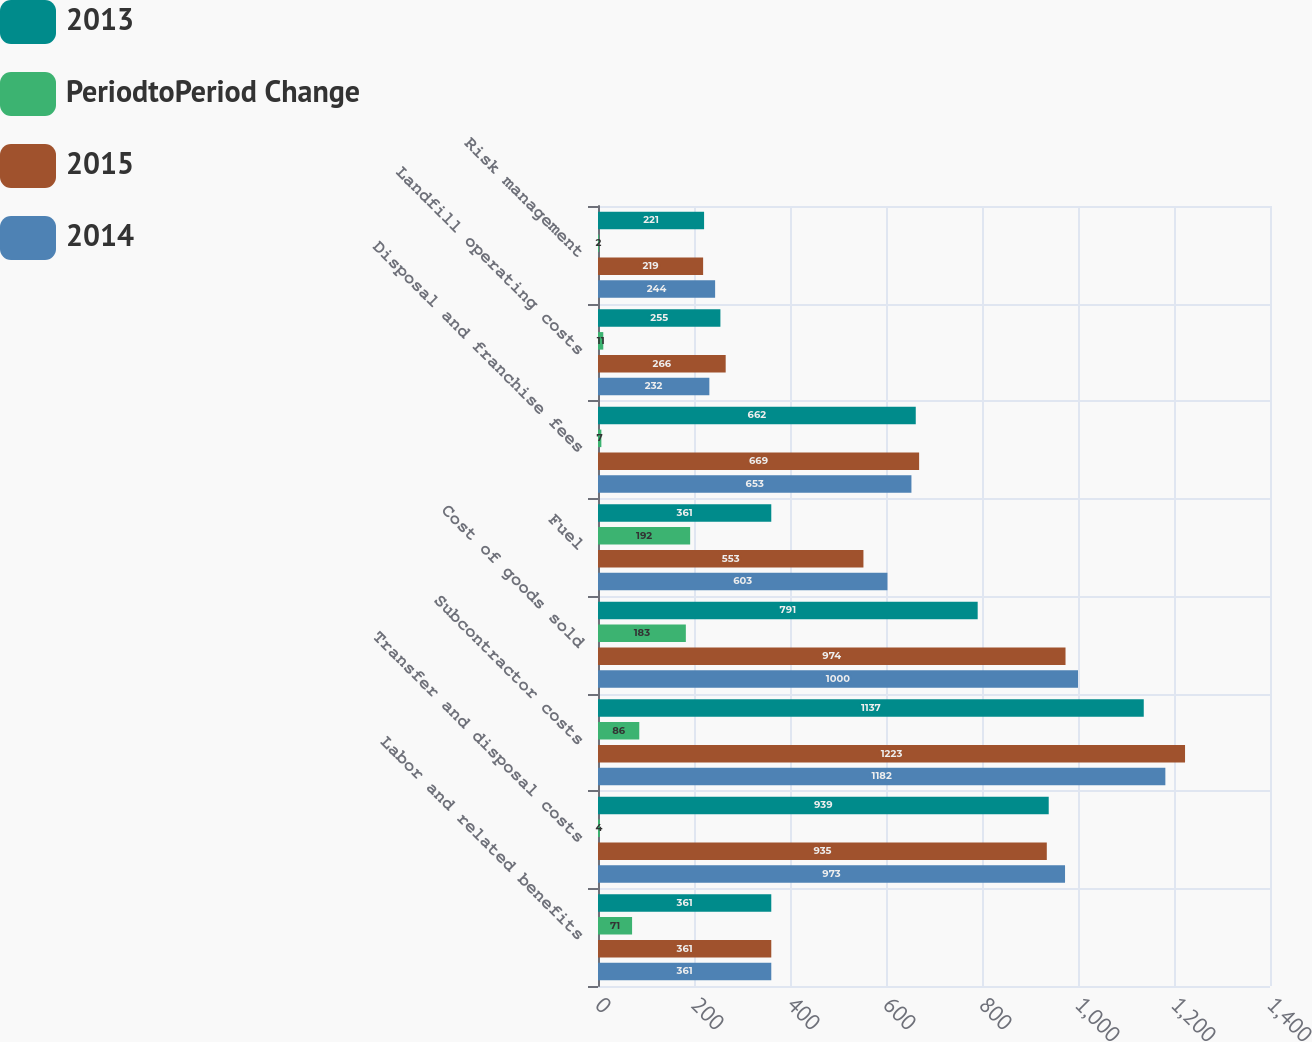Convert chart. <chart><loc_0><loc_0><loc_500><loc_500><stacked_bar_chart><ecel><fcel>Labor and related benefits<fcel>Transfer and disposal costs<fcel>Subcontractor costs<fcel>Cost of goods sold<fcel>Fuel<fcel>Disposal and franchise fees<fcel>Landfill operating costs<fcel>Risk management<nl><fcel>2013<fcel>361<fcel>939<fcel>1137<fcel>791<fcel>361<fcel>662<fcel>255<fcel>221<nl><fcel>PeriodtoPeriod Change<fcel>71<fcel>4<fcel>86<fcel>183<fcel>192<fcel>7<fcel>11<fcel>2<nl><fcel>2015<fcel>361<fcel>935<fcel>1223<fcel>974<fcel>553<fcel>669<fcel>266<fcel>219<nl><fcel>2014<fcel>361<fcel>973<fcel>1182<fcel>1000<fcel>603<fcel>653<fcel>232<fcel>244<nl></chart> 